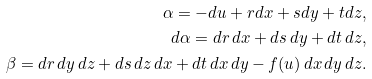Convert formula to latex. <formula><loc_0><loc_0><loc_500><loc_500>\alpha = - d u + r d x + s d y + t d z , \\ d \alpha = d r \, d x + d s \, d y + d t \, d z , \\ \beta = d r \, d y \, d z + d s \, d z \, d x + d t \, d x \, d y - f ( u ) \, d x \, d y \, d z .</formula> 